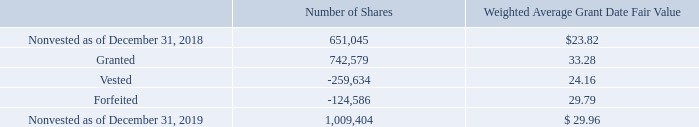Restricted Share Units
During the year ended December 31, 2019, pursuant to the 2016 Incentive Plan, the Company granted restricted share unit awards (“RSUs”). RSUs generally have requisite service periods of three years and vest in increments of 33% on the anniversary of the grant dates. RSUs granted to our board vest one year from grant or as of the next annual shareholders meeting, whichever is earlier. Under each arrangement, RSUs are issued without direct cost to the employee on the vesting date. The Company estimates the fair value of the RSUs based upon the market price of the Company’s stock at the date of grant. The Company recognizes compensation expense for RSUs on a straight-line basis over the requisite service period.
A summary of nonvested RSUs is as follows:
During the year ended December 31, 2019, a total of 259,634 RSUs vested. The Company withheld 57,802 of those shares to pay the employees’ portion of the minimum payroll withholding taxes.
As of December 31, 2019, there was unrecognized compensation expense of $20.5 million related to RSUs, $15.0 million related to TSRs, $0.5 million related to LTIP performance shares, $0.3 million related to nonvested RSAs, and $0.2 million related to nonvested stock options, which the Company expects to recognize over weighted average periods of 1.9 years, 1.9 years, 0.1 years, 0.2 years, and 0.3 years, respectively.
The Company recorded stock-based compensation expense recognized under ASC 718 during the years ended December 31, 2019, 2018, and 2017, of $36.8 million, $20.4 million, and $13.7 million, respectively, with corresponding tax benefits of $5.9 million, $3.9 million, and $1.7 million, respectively. The Company recognizes compensation expense for stock option awards that vest with only service conditions on a straight-line basis over the requisite service period. The Company recognizes compensation expense for stock option awards that vest with service and market-based conditions on a straight-line basis over the longer of the requisite service period or the estimated period to meet the defined market-based condition.
How many shares did the company withhold pay the employees’ portion of the minimum payroll withholding taxes in 2019?  57,802. What was the number of granted shares in 2019? 742,579. What was the number of vested shares in 2019? 259,634. What was the percentage of vested RSUs that the company withheld to pay the employees’ portion of the minimum payroll withholding taxes in 2019?
Answer scale should be: percent. 57,802/259,634
Answer: 22.26. What was the change in nonvested RSUs between 2018 and 2019? 1,009,404-651,045
Answer: 358359. What was the percentage change in nonvested RSUs between 2018 and 2019?
Answer scale should be: percent. (1,009,404-651,045)/651,045
Answer: 55.04. 